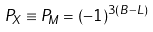Convert formula to latex. <formula><loc_0><loc_0><loc_500><loc_500>P _ { X } \equiv P _ { M } = ( - 1 ) ^ { 3 ( B - L ) }</formula> 